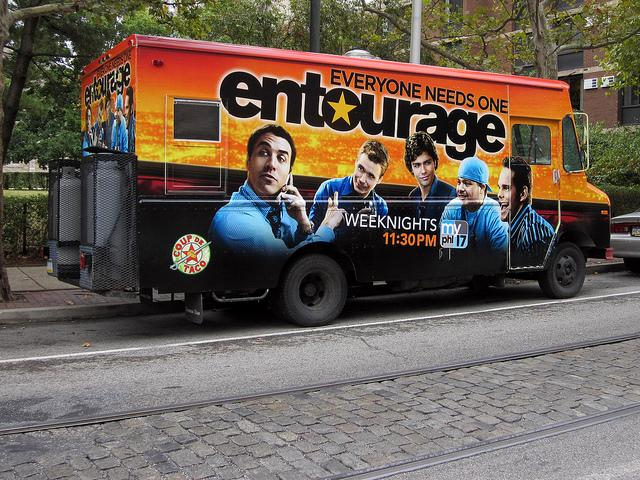Why does the van have a realistic photo on the side? Please explain your reasoning. advertising. It is promoting a show by showing the actors in the show. 